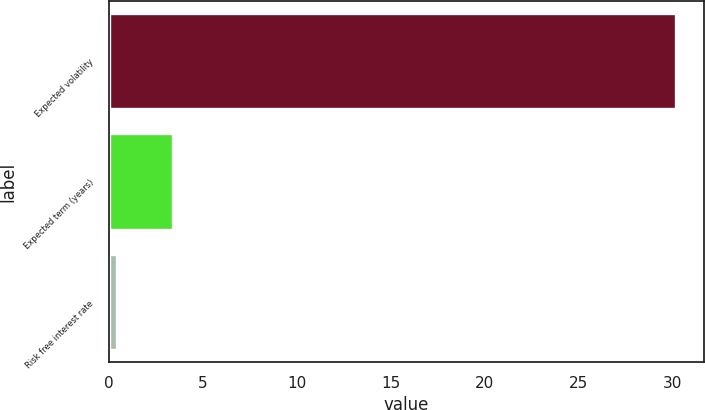Convert chart. <chart><loc_0><loc_0><loc_500><loc_500><bar_chart><fcel>Expected volatility<fcel>Expected term (years)<fcel>Risk free interest rate<nl><fcel>30.18<fcel>3.4<fcel>0.42<nl></chart> 